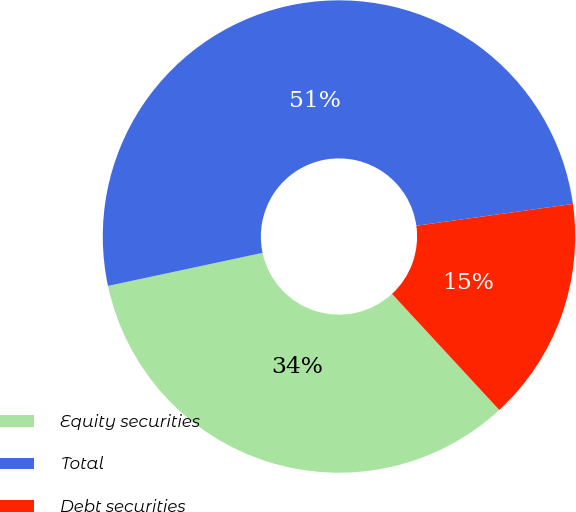Convert chart to OTSL. <chart><loc_0><loc_0><loc_500><loc_500><pie_chart><fcel>Equity securities<fcel>Total<fcel>Debt securities<nl><fcel>33.52%<fcel>51.15%<fcel>15.33%<nl></chart> 